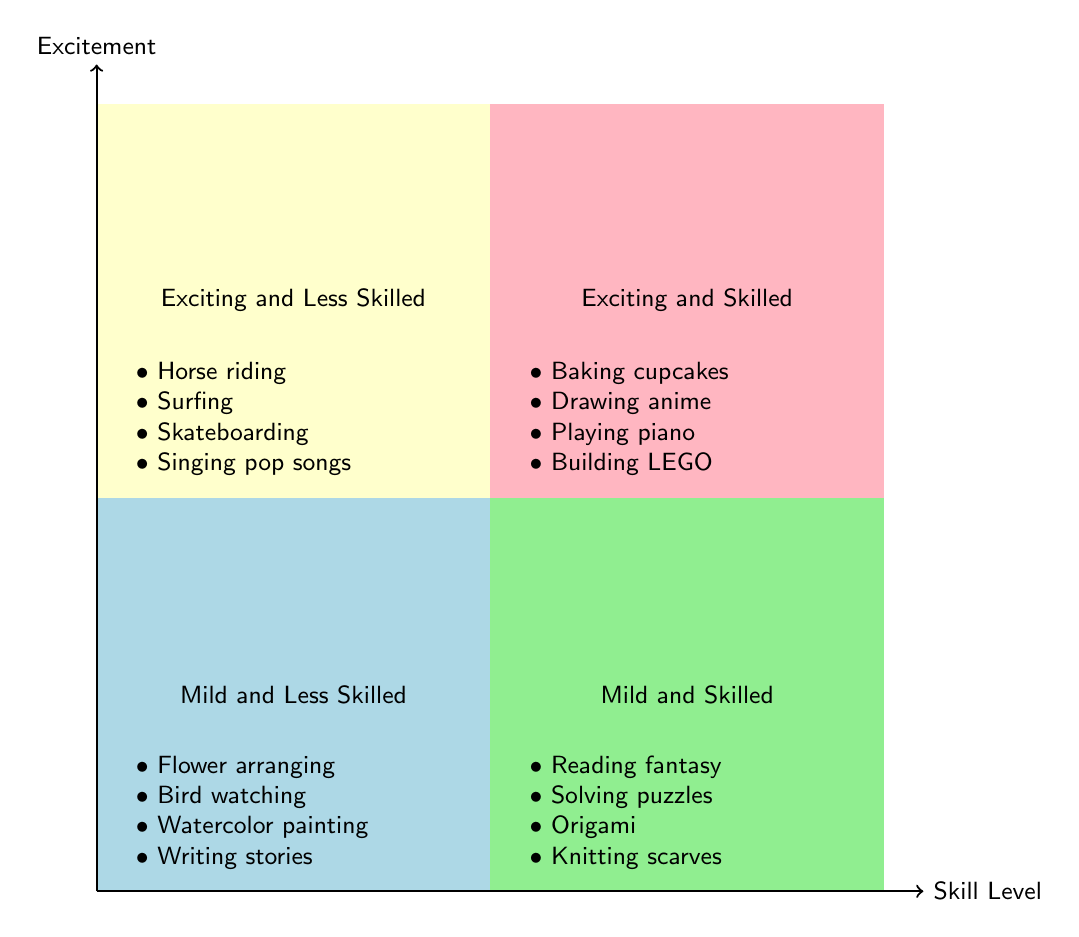What's in the "Exciting and Skilled" quadrant? The "Exciting and Skilled" quadrant contains the hobbies: Baking cupcakes, Drawing anime characters, Playing the piano, and Building LEGO sets, which can be identified visually in that specific area of the diagram.
Answer: Baking cupcakes, Drawing anime characters, Playing the piano, Building LEGO sets How many hobbies are in the "Mild and Less Skilled" quadrant? In the "Mild and Less Skilled" quadrant, we can count four hobbies listed: Flower arranging, Bird watching, Watercolor painting, and Writing short stories, confirming there are four.
Answer: 4 Which hobby is both exciting and has less skill? The hobbies listed in the "Exciting and Less Skilled" quadrant include Horse riding, Surfing, Skateboarding, and Singing pop songs, identifying any of these as a suitable answer.
Answer: Horse riding Are there any skilled hobbies that are mild in excitement? The "Mild and Skilled" quadrant lists Reading fantasy books, Solving puzzles, Origami, and Knitting scarves, confirming that these are indeed skilled but mild in excitement.
Answer: Yes Which quadrant has the hobby of "Surfing"? "Surfing" is found in the "Exciting and Less Skilled" quadrant, so by checking that specific area, we can identify it.
Answer: Exciting and Less Skilled If I want to find hobbies that are both exciting and require skill, which quadrant should I look in? The "Exciting and Skilled" quadrant contains hobbies that meet both criteria of being exciting and also requiring skill, as outlined in the diagram.
Answer: Exciting and Skilled How do "Reading fantasy books" and "Watercolor painting" differ in excitement and skill levels? "Reading fantasy books" is located in the "Mild and Skilled" quadrant, while "Watercolor painting" is in the "Mild and Less Skilled" quadrant, indicating the former is skilled and mild, and the latter is less skilled and mild.
Answer: Reading fantasy books is skilled and mild; Watercolor painting is less skilled and mild Which hobby is the least skilled out of all listed? The "Watercolor painting" hobby is in the "Mild and Less Skilled" quadrant, which indicates that it has the least skill level compared to others.
Answer: Watercolor painting 